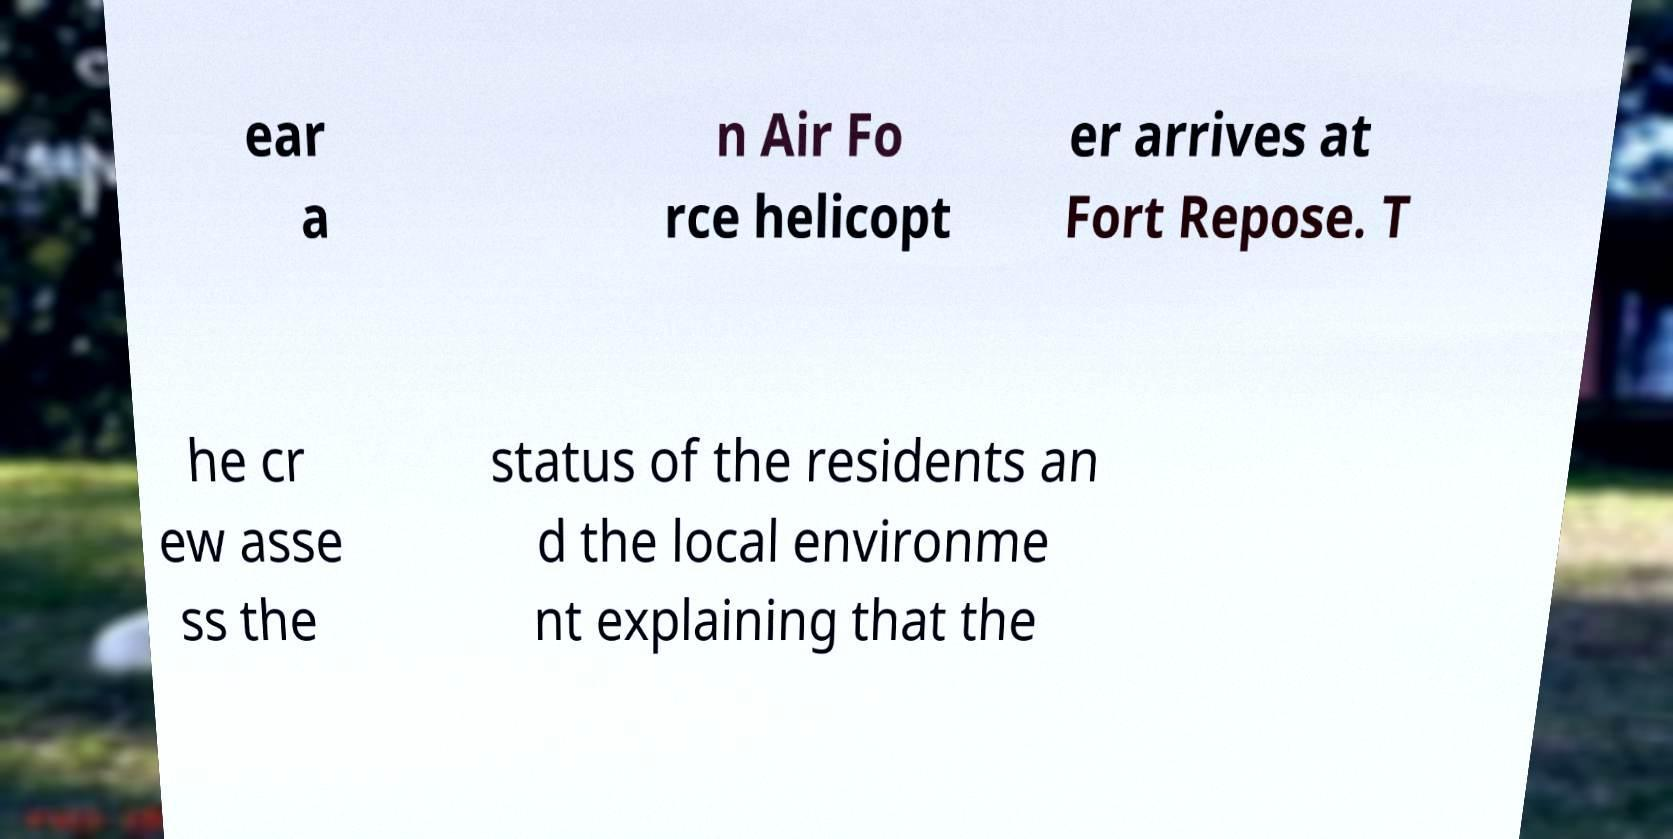Can you accurately transcribe the text from the provided image for me? ear a n Air Fo rce helicopt er arrives at Fort Repose. T he cr ew asse ss the status of the residents an d the local environme nt explaining that the 